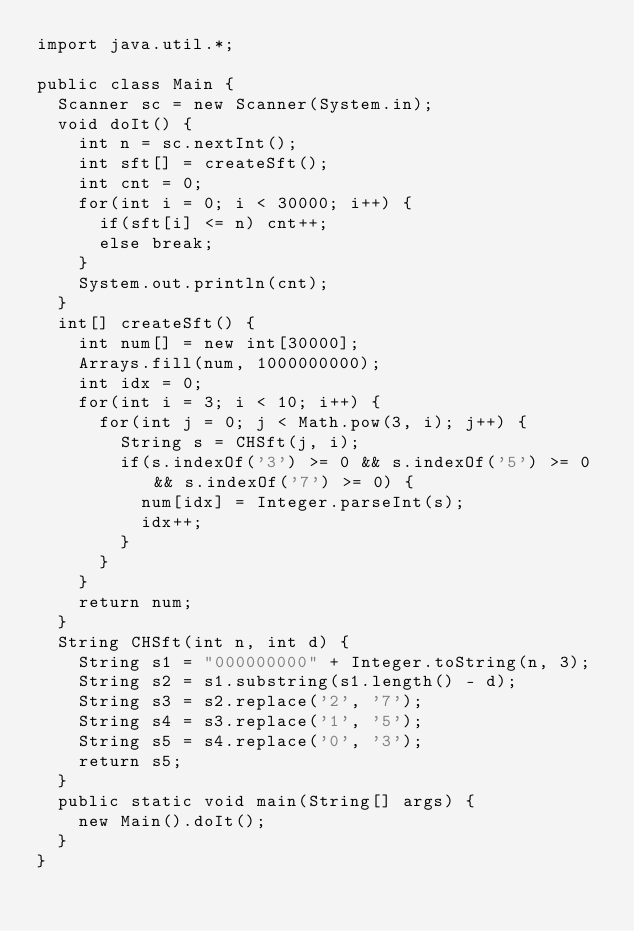Convert code to text. <code><loc_0><loc_0><loc_500><loc_500><_Java_>import java.util.*;

public class Main {
	Scanner sc = new Scanner(System.in);
	void doIt() {
		int n = sc.nextInt();
		int sft[] = createSft();
		int cnt = 0;
		for(int i = 0; i < 30000; i++) {
			if(sft[i] <= n) cnt++;
			else break;
		}
		System.out.println(cnt);
	}
	int[] createSft() {
		int num[] = new int[30000];
		Arrays.fill(num, 1000000000);
		int idx = 0;
		for(int i = 3; i < 10; i++) {
			for(int j = 0; j < Math.pow(3, i); j++) {
				String s = CHSft(j, i);
				if(s.indexOf('3') >= 0 && s.indexOf('5') >= 0 && s.indexOf('7') >= 0) {
					num[idx] = Integer.parseInt(s);
					idx++;
				}
			}
		}
		return num;
	}
	String CHSft(int n, int d) {
		String s1 = "000000000" + Integer.toString(n, 3);
		String s2 = s1.substring(s1.length() - d);
		String s3 = s2.replace('2', '7');
		String s4 = s3.replace('1', '5');
		String s5 = s4.replace('0', '3');
		return s5;
	}
	public static void main(String[] args) {
		new Main().doIt();
	}
}
</code> 